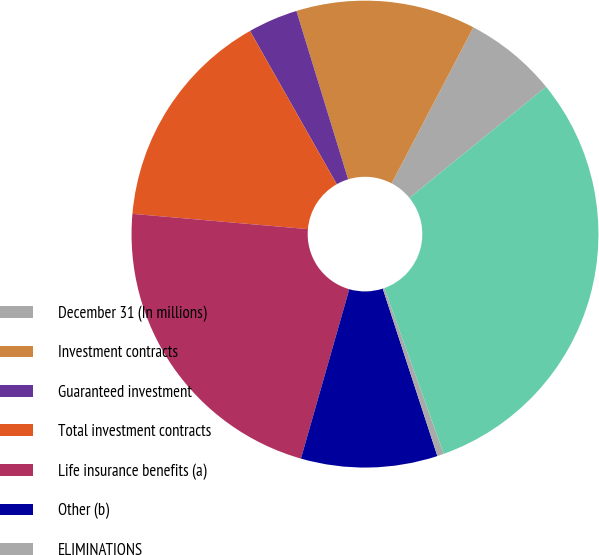<chart> <loc_0><loc_0><loc_500><loc_500><pie_chart><fcel>December 31 (In millions)<fcel>Investment contracts<fcel>Guaranteed investment<fcel>Total investment contracts<fcel>Life insurance benefits (a)<fcel>Other (b)<fcel>ELIMINATIONS<fcel>Total<nl><fcel>6.45%<fcel>12.43%<fcel>3.45%<fcel>15.42%<fcel>21.96%<fcel>9.44%<fcel>0.46%<fcel>30.39%<nl></chart> 